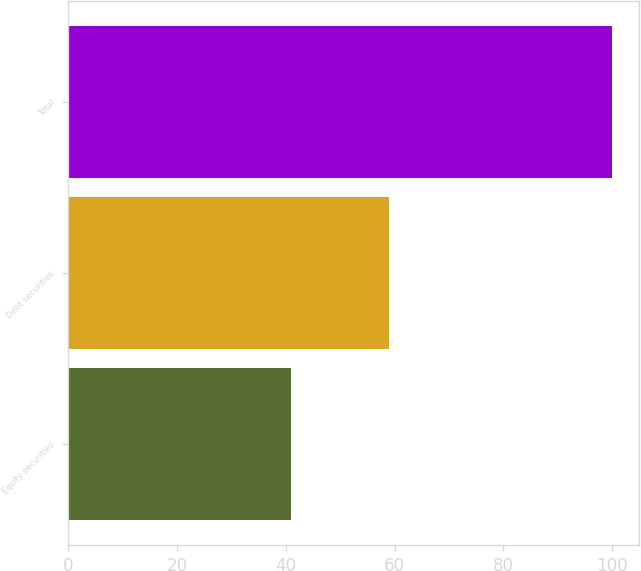Convert chart. <chart><loc_0><loc_0><loc_500><loc_500><bar_chart><fcel>Equity securities<fcel>Debt securities<fcel>Total<nl><fcel>41<fcel>59<fcel>100<nl></chart> 